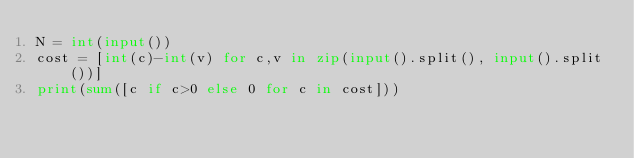<code> <loc_0><loc_0><loc_500><loc_500><_Python_>N = int(input())
cost = [int(c)-int(v) for c,v in zip(input().split(), input().split())]
print(sum([c if c>0 else 0 for c in cost]))</code> 